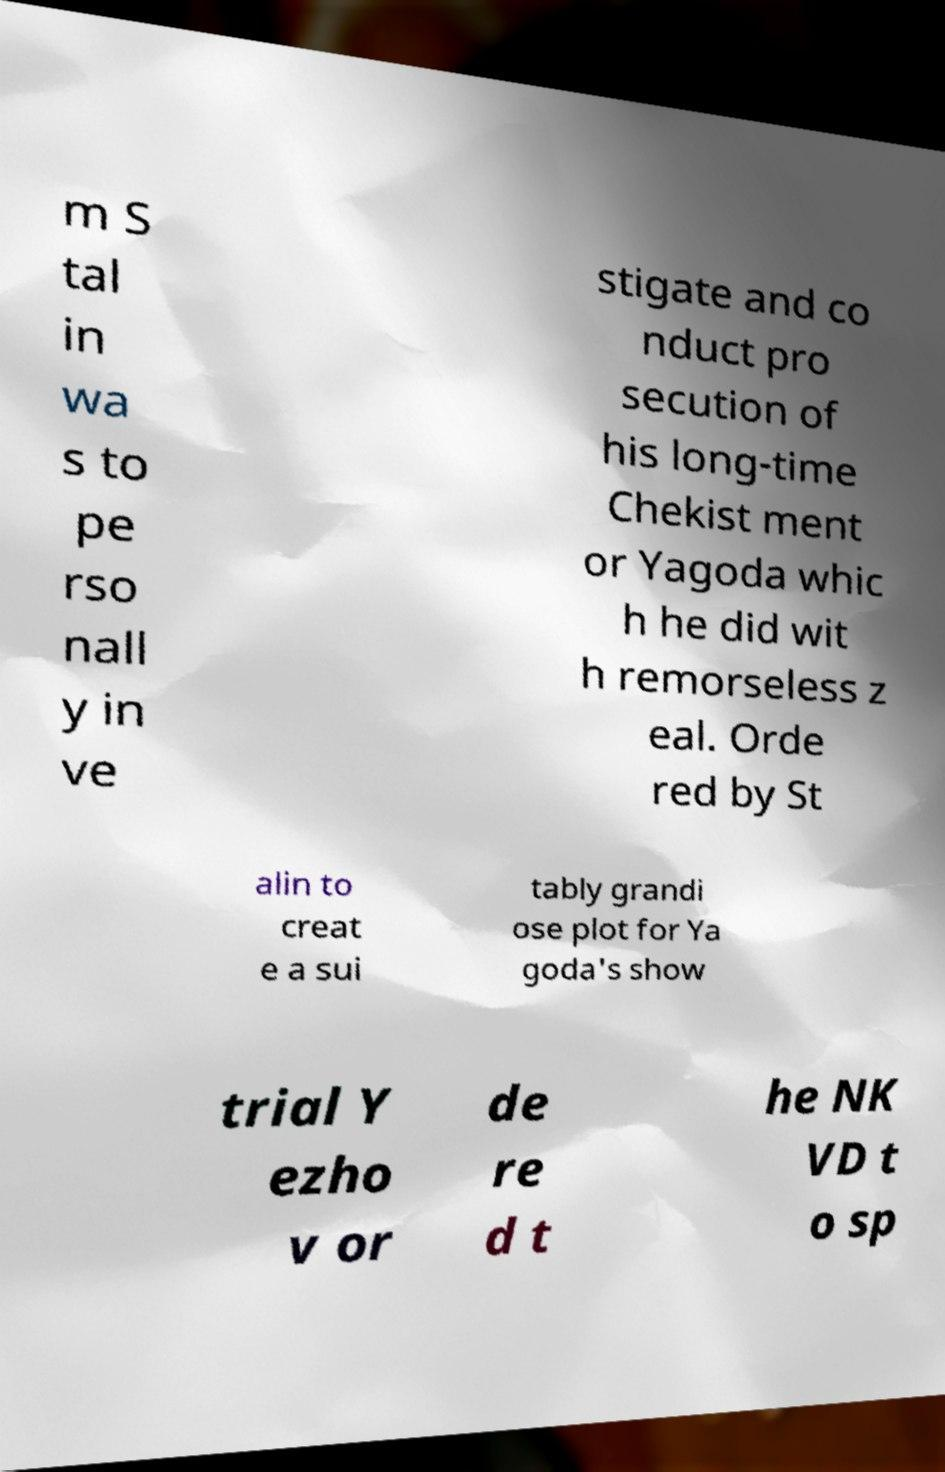Can you read and provide the text displayed in the image?This photo seems to have some interesting text. Can you extract and type it out for me? m S tal in wa s to pe rso nall y in ve stigate and co nduct pro secution of his long-time Chekist ment or Yagoda whic h he did wit h remorseless z eal. Orde red by St alin to creat e a sui tably grandi ose plot for Ya goda's show trial Y ezho v or de re d t he NK VD t o sp 